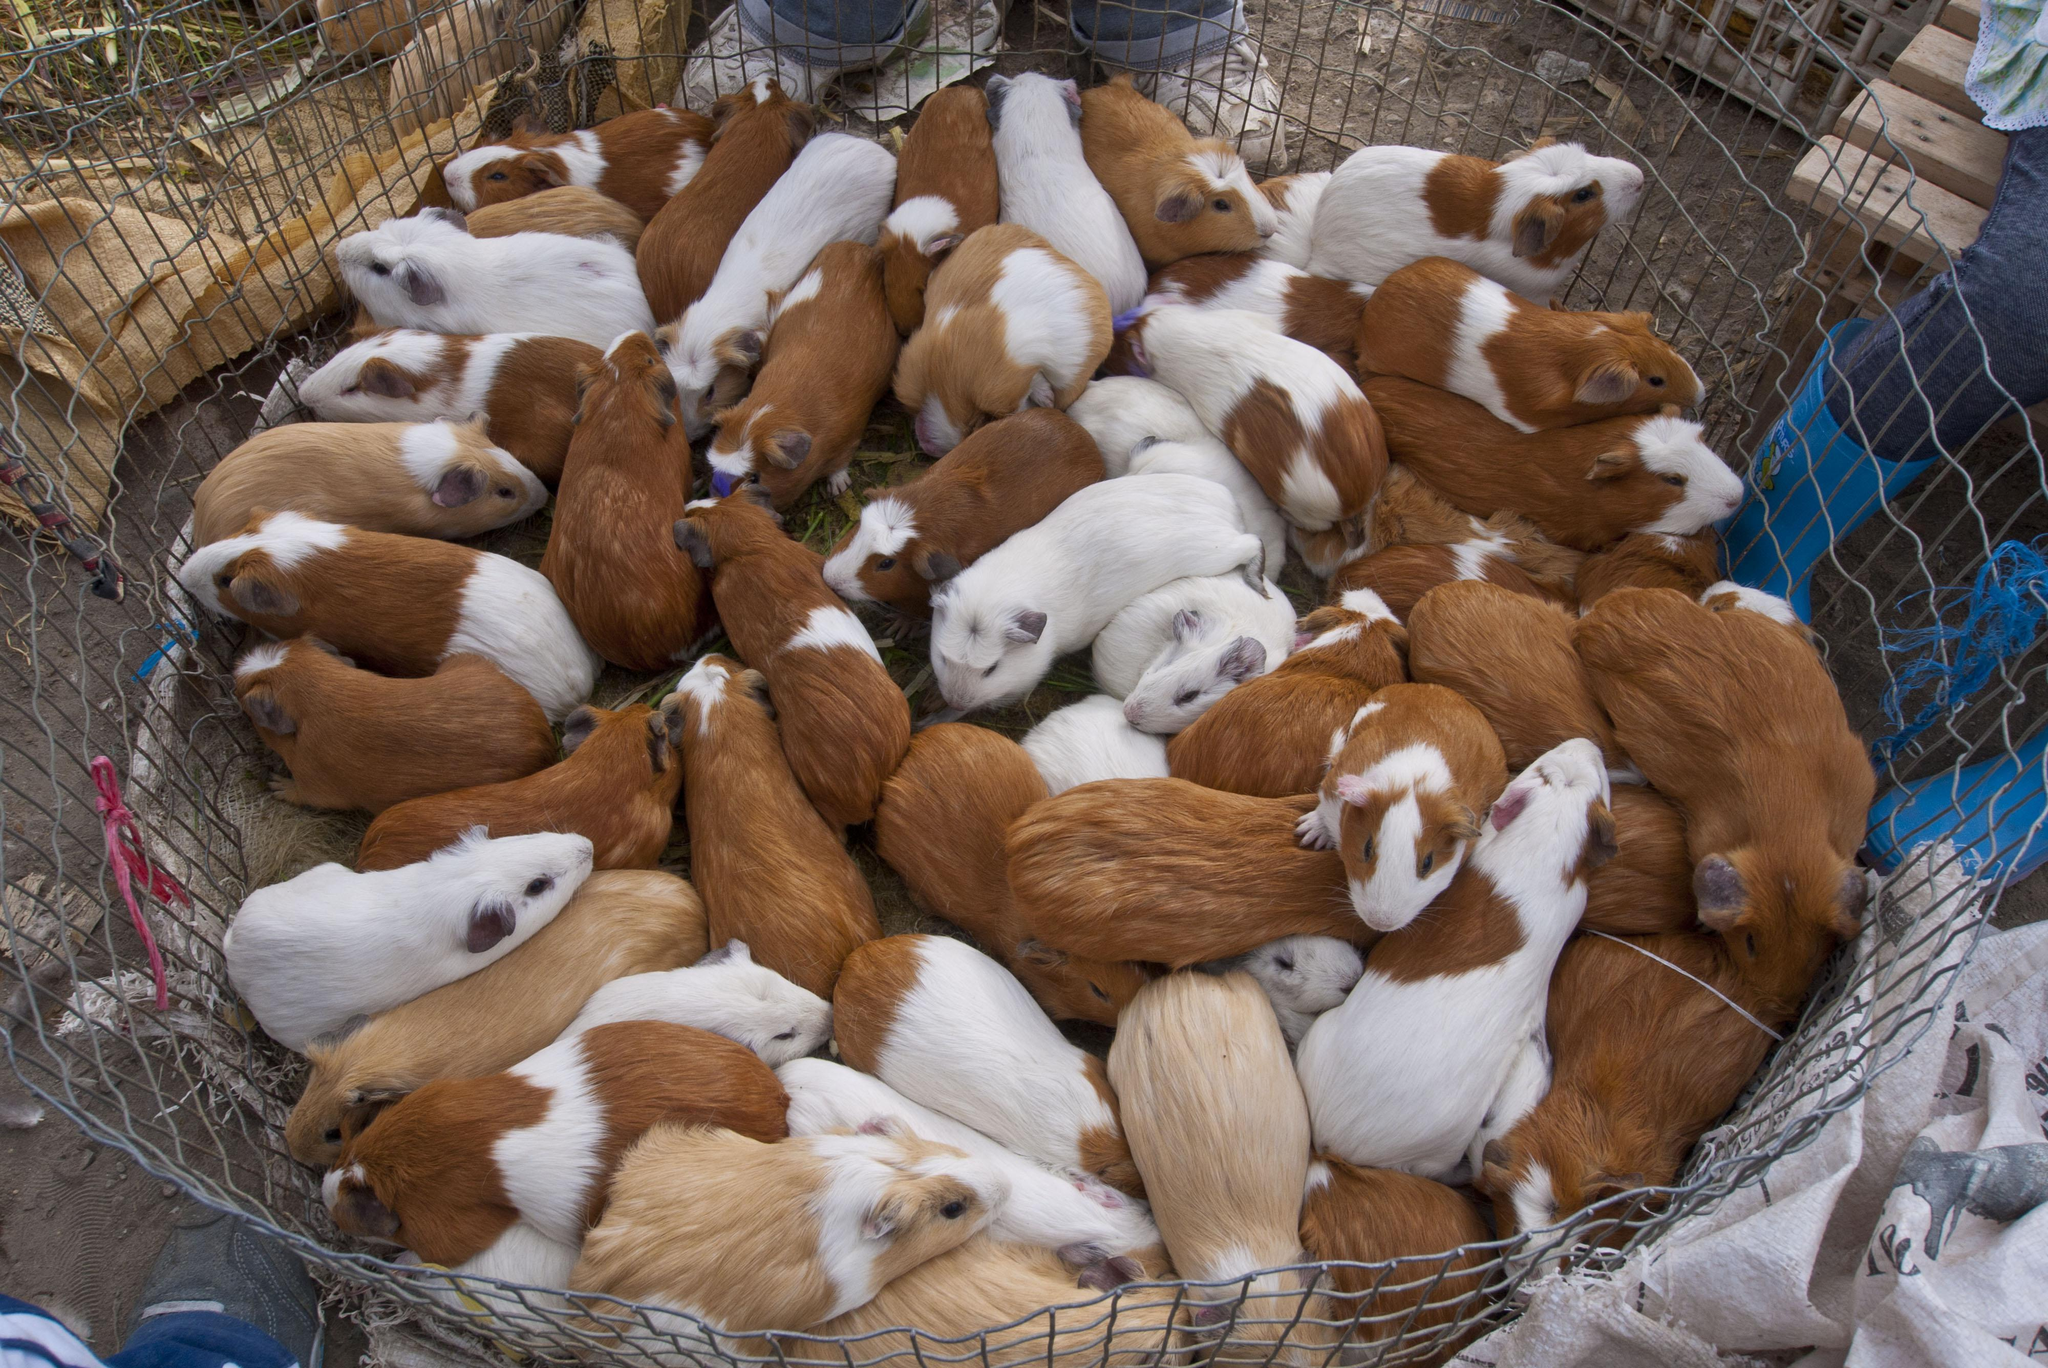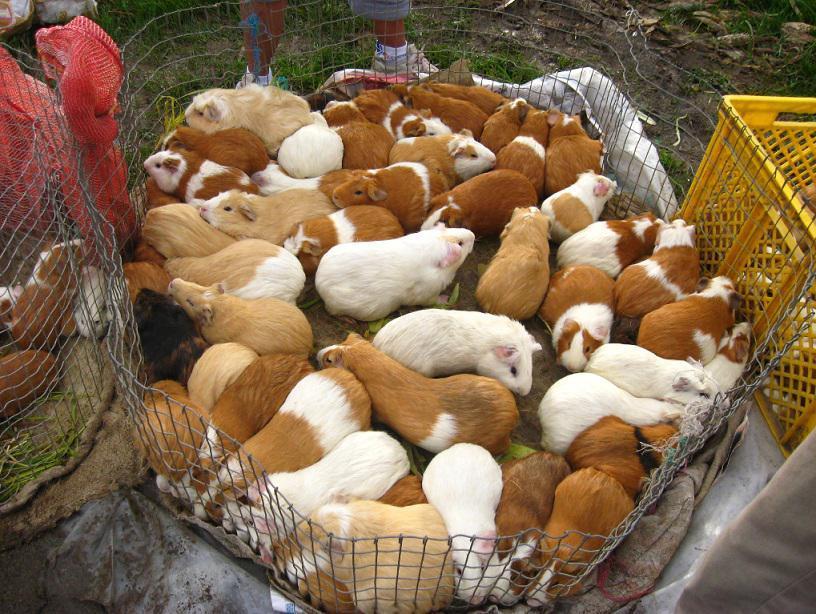The first image is the image on the left, the second image is the image on the right. Examine the images to the left and right. Is the description "There are no more than five animals" accurate? Answer yes or no. No. The first image is the image on the left, the second image is the image on the right. Evaluate the accuracy of this statement regarding the images: "There are exactly three rodents in the image on the left.". Is it true? Answer yes or no. No. 